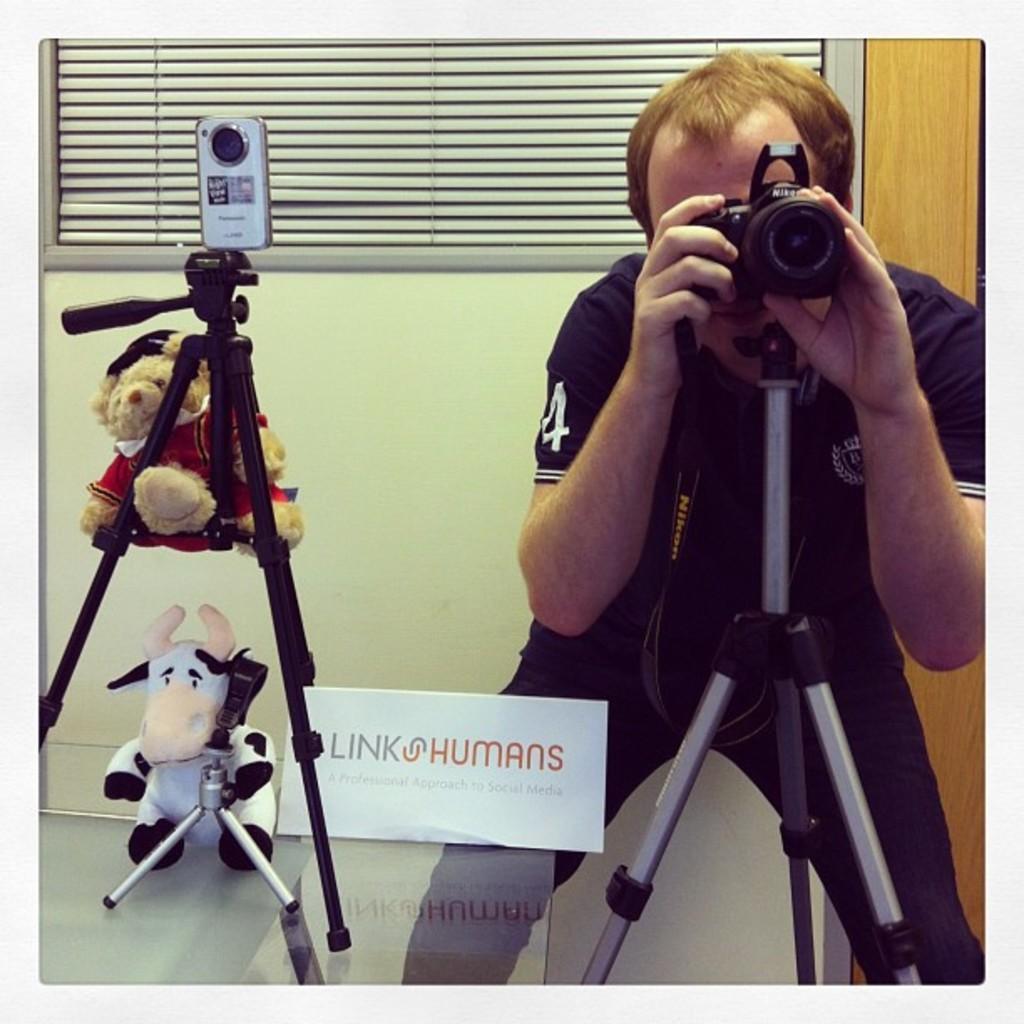In one or two sentences, can you explain what this image depicts? In this image there is a man taking the picture with the camera. In front of him there is a tripod on which there is a camera. On the left side there is another tripod on which there is a camera. There are two dolls to the tripod. In the background there is a curtain. 